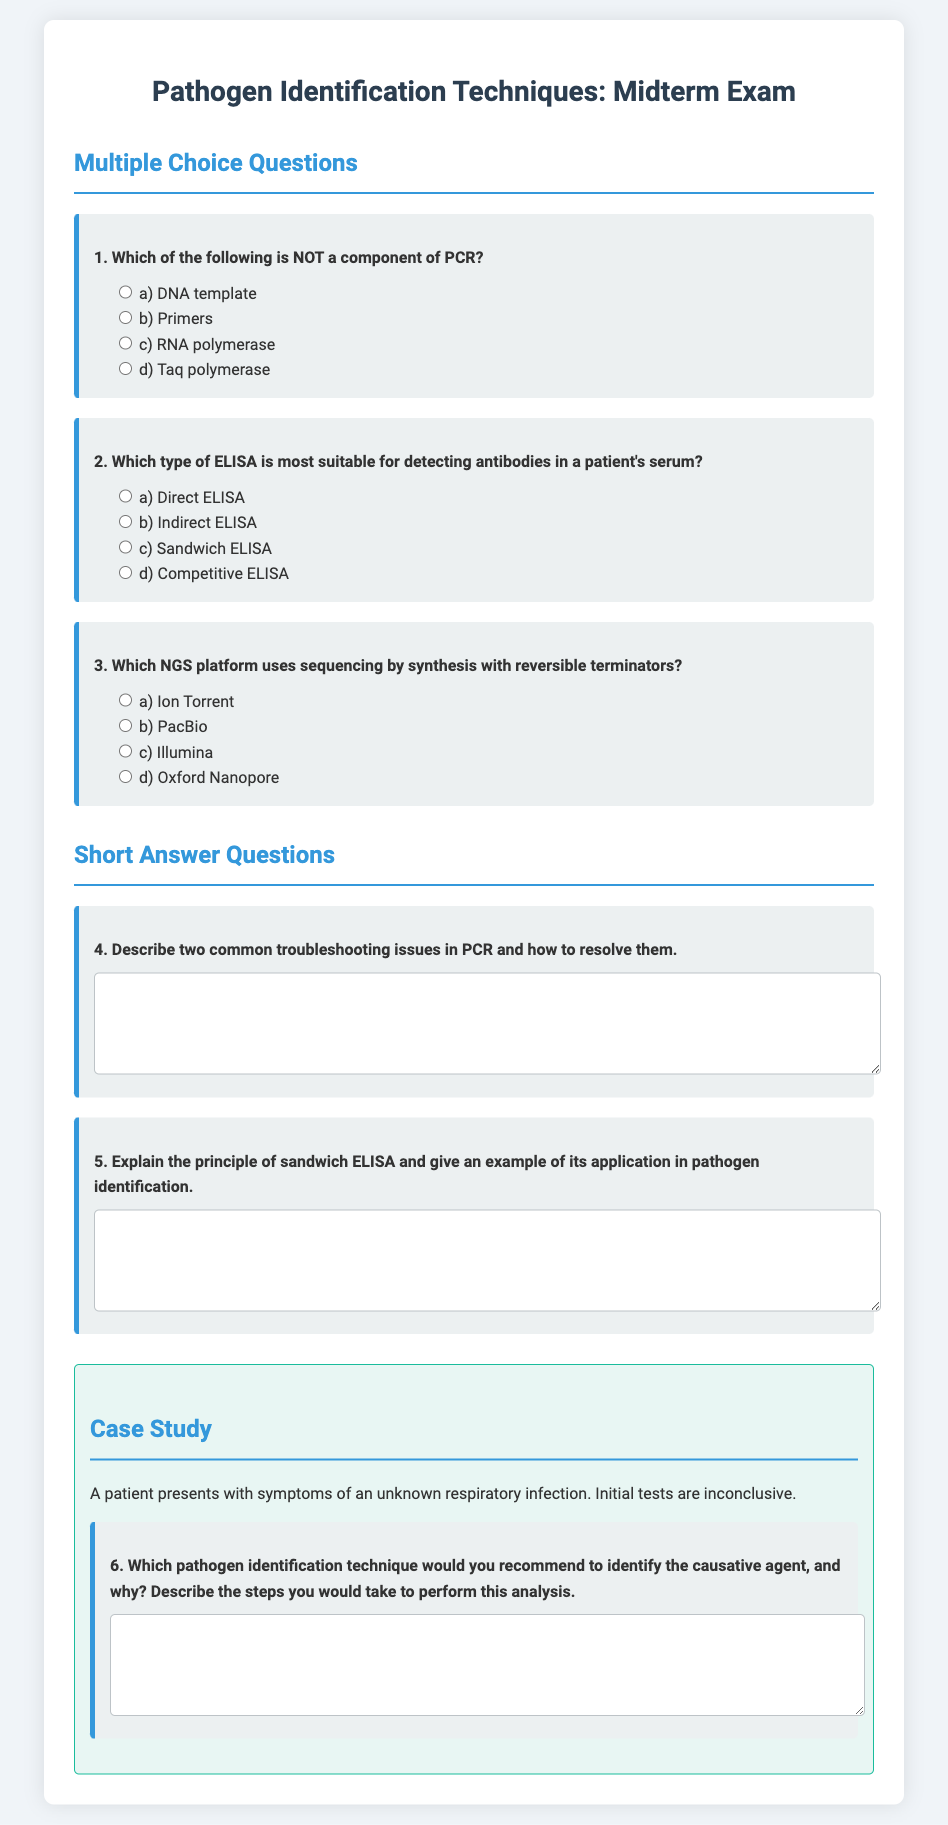What is the title of the document? The title of the document is specified in the header section of the HTML code.
Answer: Pathogen Identification Techniques: Midterm Exam How many multiple choice questions are there? The document clearly lists multiple choice questions in a section.
Answer: 3 What is the main focus of the midterm exam? The midterm exam assesses knowledge on specific laboratory techniques and troubleshooting.
Answer: Pathogen identification techniques In which section can you find short answer questions? The short answer questions are grouped in a specific section titled accordingly in the document.
Answer: Short Answer Questions What type of ELISA is most suitable for detecting antibodies? The document provides a multiple choice question regarding different types of ELISA.
Answer: Indirect ELISA What troubleshooting issues in PCR are mentioned in the exam? The short answer question prompts to describe troubleshooting issues related to PCR.
Answer: Not specified in the document, it's an open question Which sequencing platform uses sequencing by synthesis? The question lists options for NGS platforms and identifies one specific platform.
Answer: Illumina What does the case study involve? The case study section describes a patient's symptoms and initial test results.
Answer: Unknown respiratory infection 